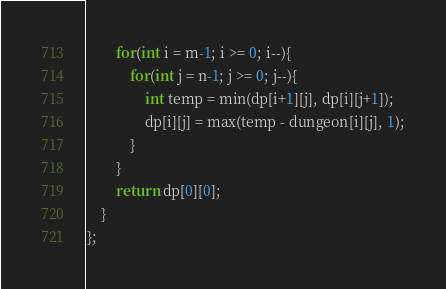<code> <loc_0><loc_0><loc_500><loc_500><_C++_>        for(int i = m-1; i >= 0; i--){
            for(int j = n-1; j >= 0; j--){
                int temp = min(dp[i+1][j], dp[i][j+1]);
                dp[i][j] = max(temp - dungeon[i][j], 1);
            }
        }
        return dp[0][0];
    }
};</code> 